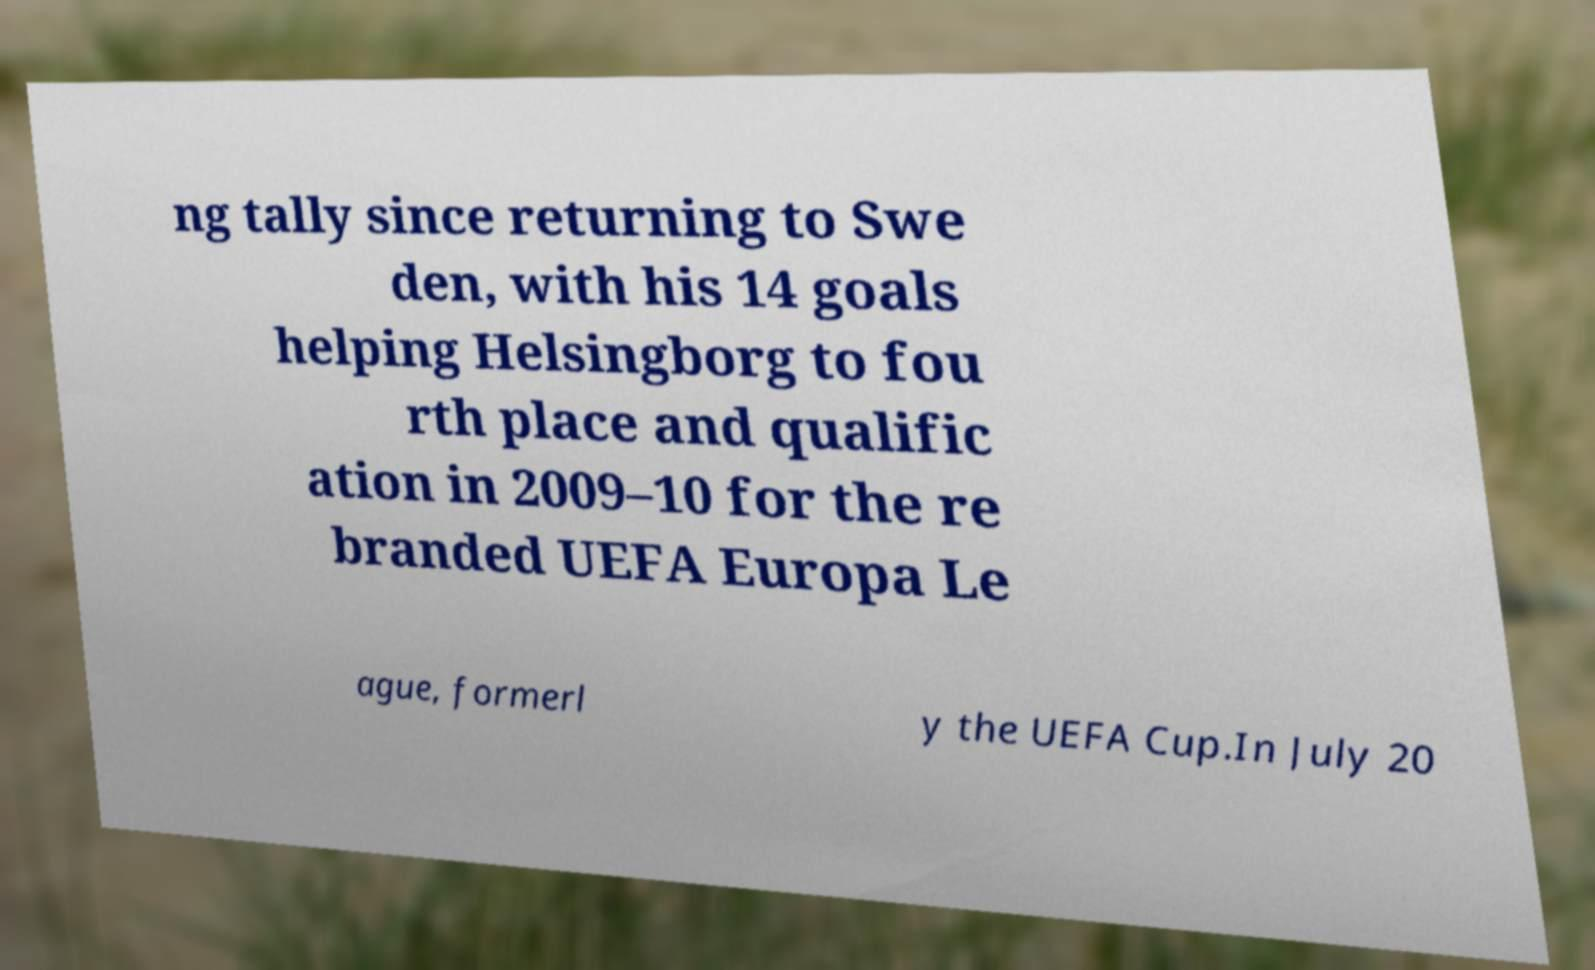Could you extract and type out the text from this image? ng tally since returning to Swe den, with his 14 goals helping Helsingborg to fou rth place and qualific ation in 2009–10 for the re branded UEFA Europa Le ague, formerl y the UEFA Cup.In July 20 